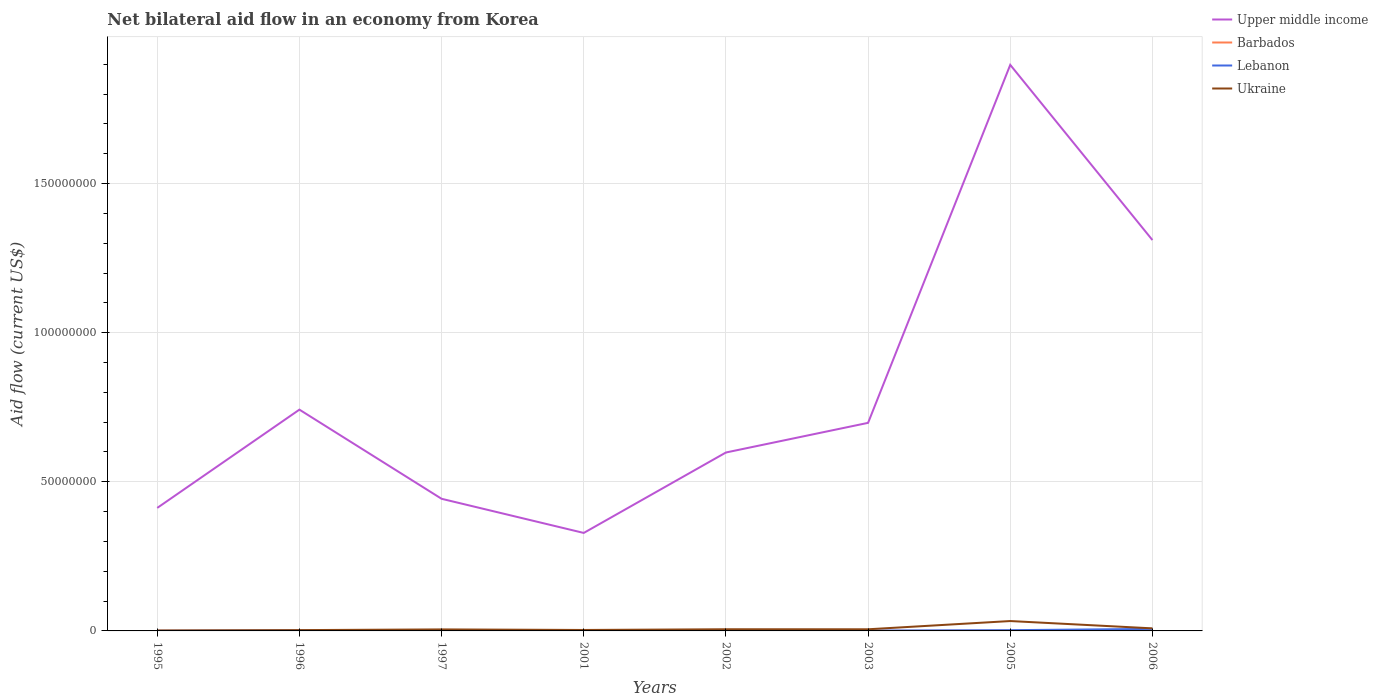How many different coloured lines are there?
Ensure brevity in your answer.  4. Across all years, what is the maximum net bilateral aid flow in Barbados?
Offer a terse response. 10000. What is the total net bilateral aid flow in Lebanon in the graph?
Offer a very short reply. -6.00e+05. What is the difference between the highest and the second highest net bilateral aid flow in Ukraine?
Provide a succinct answer. 3.17e+06. What is the difference between the highest and the lowest net bilateral aid flow in Lebanon?
Your answer should be compact. 2. How many years are there in the graph?
Make the answer very short. 8. What is the difference between two consecutive major ticks on the Y-axis?
Give a very brief answer. 5.00e+07. Are the values on the major ticks of Y-axis written in scientific E-notation?
Your answer should be compact. No. Does the graph contain grids?
Make the answer very short. Yes. Where does the legend appear in the graph?
Ensure brevity in your answer.  Top right. What is the title of the graph?
Make the answer very short. Net bilateral aid flow in an economy from Korea. What is the label or title of the X-axis?
Keep it short and to the point. Years. What is the Aid flow (current US$) in Upper middle income in 1995?
Your answer should be very brief. 4.12e+07. What is the Aid flow (current US$) in Barbados in 1995?
Offer a terse response. 3.00e+04. What is the Aid flow (current US$) in Lebanon in 1995?
Offer a very short reply. 3.00e+04. What is the Aid flow (current US$) of Upper middle income in 1996?
Provide a short and direct response. 7.42e+07. What is the Aid flow (current US$) in Upper middle income in 1997?
Offer a very short reply. 4.43e+07. What is the Aid flow (current US$) in Lebanon in 1997?
Make the answer very short. 1.20e+05. What is the Aid flow (current US$) in Ukraine in 1997?
Provide a succinct answer. 5.10e+05. What is the Aid flow (current US$) of Upper middle income in 2001?
Make the answer very short. 3.28e+07. What is the Aid flow (current US$) in Barbados in 2001?
Make the answer very short. 10000. What is the Aid flow (current US$) of Lebanon in 2001?
Offer a very short reply. 8.00e+04. What is the Aid flow (current US$) of Ukraine in 2001?
Provide a short and direct response. 3.20e+05. What is the Aid flow (current US$) of Upper middle income in 2002?
Provide a short and direct response. 5.98e+07. What is the Aid flow (current US$) of Barbados in 2002?
Your response must be concise. 9.00e+04. What is the Aid flow (current US$) in Lebanon in 2002?
Ensure brevity in your answer.  9.00e+04. What is the Aid flow (current US$) of Ukraine in 2002?
Offer a very short reply. 5.60e+05. What is the Aid flow (current US$) in Upper middle income in 2003?
Keep it short and to the point. 6.98e+07. What is the Aid flow (current US$) of Lebanon in 2003?
Offer a very short reply. 1.20e+05. What is the Aid flow (current US$) in Upper middle income in 2005?
Your response must be concise. 1.90e+08. What is the Aid flow (current US$) in Lebanon in 2005?
Your answer should be compact. 2.50e+05. What is the Aid flow (current US$) in Ukraine in 2005?
Your answer should be compact. 3.31e+06. What is the Aid flow (current US$) of Upper middle income in 2006?
Provide a succinct answer. 1.31e+08. What is the Aid flow (current US$) of Lebanon in 2006?
Offer a terse response. 6.80e+05. What is the Aid flow (current US$) of Ukraine in 2006?
Give a very brief answer. 8.60e+05. Across all years, what is the maximum Aid flow (current US$) in Upper middle income?
Keep it short and to the point. 1.90e+08. Across all years, what is the maximum Aid flow (current US$) of Barbados?
Offer a terse response. 9.00e+04. Across all years, what is the maximum Aid flow (current US$) of Lebanon?
Provide a short and direct response. 6.80e+05. Across all years, what is the maximum Aid flow (current US$) of Ukraine?
Provide a succinct answer. 3.31e+06. Across all years, what is the minimum Aid flow (current US$) of Upper middle income?
Your answer should be compact. 3.28e+07. Across all years, what is the minimum Aid flow (current US$) in Barbados?
Your response must be concise. 10000. Across all years, what is the minimum Aid flow (current US$) in Lebanon?
Provide a short and direct response. 3.00e+04. Across all years, what is the minimum Aid flow (current US$) in Ukraine?
Your response must be concise. 1.40e+05. What is the total Aid flow (current US$) in Upper middle income in the graph?
Provide a short and direct response. 6.43e+08. What is the total Aid flow (current US$) of Lebanon in the graph?
Ensure brevity in your answer.  1.52e+06. What is the total Aid flow (current US$) of Ukraine in the graph?
Your answer should be compact. 6.52e+06. What is the difference between the Aid flow (current US$) of Upper middle income in 1995 and that in 1996?
Make the answer very short. -3.30e+07. What is the difference between the Aid flow (current US$) of Barbados in 1995 and that in 1996?
Provide a short and direct response. 0. What is the difference between the Aid flow (current US$) in Upper middle income in 1995 and that in 1997?
Your answer should be compact. -3.06e+06. What is the difference between the Aid flow (current US$) in Ukraine in 1995 and that in 1997?
Offer a terse response. -3.70e+05. What is the difference between the Aid flow (current US$) in Upper middle income in 1995 and that in 2001?
Offer a very short reply. 8.39e+06. What is the difference between the Aid flow (current US$) of Barbados in 1995 and that in 2001?
Ensure brevity in your answer.  2.00e+04. What is the difference between the Aid flow (current US$) of Upper middle income in 1995 and that in 2002?
Make the answer very short. -1.86e+07. What is the difference between the Aid flow (current US$) in Barbados in 1995 and that in 2002?
Offer a terse response. -6.00e+04. What is the difference between the Aid flow (current US$) in Lebanon in 1995 and that in 2002?
Give a very brief answer. -6.00e+04. What is the difference between the Aid flow (current US$) in Ukraine in 1995 and that in 2002?
Your answer should be very brief. -4.20e+05. What is the difference between the Aid flow (current US$) of Upper middle income in 1995 and that in 2003?
Offer a very short reply. -2.85e+07. What is the difference between the Aid flow (current US$) of Barbados in 1995 and that in 2003?
Ensure brevity in your answer.  2.00e+04. What is the difference between the Aid flow (current US$) of Lebanon in 1995 and that in 2003?
Provide a short and direct response. -9.00e+04. What is the difference between the Aid flow (current US$) of Ukraine in 1995 and that in 2003?
Your response must be concise. -4.10e+05. What is the difference between the Aid flow (current US$) of Upper middle income in 1995 and that in 2005?
Offer a terse response. -1.49e+08. What is the difference between the Aid flow (current US$) of Ukraine in 1995 and that in 2005?
Make the answer very short. -3.17e+06. What is the difference between the Aid flow (current US$) of Upper middle income in 1995 and that in 2006?
Keep it short and to the point. -8.98e+07. What is the difference between the Aid flow (current US$) of Barbados in 1995 and that in 2006?
Provide a succinct answer. -2.00e+04. What is the difference between the Aid flow (current US$) of Lebanon in 1995 and that in 2006?
Provide a succinct answer. -6.50e+05. What is the difference between the Aid flow (current US$) of Ukraine in 1995 and that in 2006?
Keep it short and to the point. -7.20e+05. What is the difference between the Aid flow (current US$) of Upper middle income in 1996 and that in 1997?
Offer a terse response. 2.99e+07. What is the difference between the Aid flow (current US$) in Barbados in 1996 and that in 1997?
Your answer should be very brief. 10000. What is the difference between the Aid flow (current US$) in Upper middle income in 1996 and that in 2001?
Ensure brevity in your answer.  4.13e+07. What is the difference between the Aid flow (current US$) of Ukraine in 1996 and that in 2001?
Make the answer very short. -5.00e+04. What is the difference between the Aid flow (current US$) in Upper middle income in 1996 and that in 2002?
Ensure brevity in your answer.  1.44e+07. What is the difference between the Aid flow (current US$) in Barbados in 1996 and that in 2002?
Your answer should be compact. -6.00e+04. What is the difference between the Aid flow (current US$) of Lebanon in 1996 and that in 2002?
Provide a succinct answer. 6.00e+04. What is the difference between the Aid flow (current US$) in Upper middle income in 1996 and that in 2003?
Offer a terse response. 4.43e+06. What is the difference between the Aid flow (current US$) in Ukraine in 1996 and that in 2003?
Provide a short and direct response. -2.80e+05. What is the difference between the Aid flow (current US$) of Upper middle income in 1996 and that in 2005?
Provide a succinct answer. -1.16e+08. What is the difference between the Aid flow (current US$) in Barbados in 1996 and that in 2005?
Your answer should be very brief. -2.00e+04. What is the difference between the Aid flow (current US$) of Lebanon in 1996 and that in 2005?
Your response must be concise. -1.00e+05. What is the difference between the Aid flow (current US$) in Ukraine in 1996 and that in 2005?
Keep it short and to the point. -3.04e+06. What is the difference between the Aid flow (current US$) of Upper middle income in 1996 and that in 2006?
Offer a terse response. -5.69e+07. What is the difference between the Aid flow (current US$) of Lebanon in 1996 and that in 2006?
Your response must be concise. -5.30e+05. What is the difference between the Aid flow (current US$) in Ukraine in 1996 and that in 2006?
Make the answer very short. -5.90e+05. What is the difference between the Aid flow (current US$) of Upper middle income in 1997 and that in 2001?
Give a very brief answer. 1.14e+07. What is the difference between the Aid flow (current US$) in Upper middle income in 1997 and that in 2002?
Make the answer very short. -1.55e+07. What is the difference between the Aid flow (current US$) in Lebanon in 1997 and that in 2002?
Provide a succinct answer. 3.00e+04. What is the difference between the Aid flow (current US$) in Ukraine in 1997 and that in 2002?
Keep it short and to the point. -5.00e+04. What is the difference between the Aid flow (current US$) in Upper middle income in 1997 and that in 2003?
Provide a short and direct response. -2.55e+07. What is the difference between the Aid flow (current US$) in Barbados in 1997 and that in 2003?
Ensure brevity in your answer.  10000. What is the difference between the Aid flow (current US$) in Ukraine in 1997 and that in 2003?
Offer a very short reply. -4.00e+04. What is the difference between the Aid flow (current US$) of Upper middle income in 1997 and that in 2005?
Provide a short and direct response. -1.45e+08. What is the difference between the Aid flow (current US$) of Lebanon in 1997 and that in 2005?
Make the answer very short. -1.30e+05. What is the difference between the Aid flow (current US$) in Ukraine in 1997 and that in 2005?
Make the answer very short. -2.80e+06. What is the difference between the Aid flow (current US$) of Upper middle income in 1997 and that in 2006?
Ensure brevity in your answer.  -8.68e+07. What is the difference between the Aid flow (current US$) of Lebanon in 1997 and that in 2006?
Keep it short and to the point. -5.60e+05. What is the difference between the Aid flow (current US$) of Ukraine in 1997 and that in 2006?
Your answer should be very brief. -3.50e+05. What is the difference between the Aid flow (current US$) in Upper middle income in 2001 and that in 2002?
Your answer should be very brief. -2.70e+07. What is the difference between the Aid flow (current US$) of Ukraine in 2001 and that in 2002?
Give a very brief answer. -2.40e+05. What is the difference between the Aid flow (current US$) in Upper middle income in 2001 and that in 2003?
Offer a terse response. -3.69e+07. What is the difference between the Aid flow (current US$) in Barbados in 2001 and that in 2003?
Offer a very short reply. 0. What is the difference between the Aid flow (current US$) in Lebanon in 2001 and that in 2003?
Offer a terse response. -4.00e+04. What is the difference between the Aid flow (current US$) in Upper middle income in 2001 and that in 2005?
Your answer should be very brief. -1.57e+08. What is the difference between the Aid flow (current US$) of Ukraine in 2001 and that in 2005?
Provide a succinct answer. -2.99e+06. What is the difference between the Aid flow (current US$) in Upper middle income in 2001 and that in 2006?
Provide a short and direct response. -9.82e+07. What is the difference between the Aid flow (current US$) in Barbados in 2001 and that in 2006?
Keep it short and to the point. -4.00e+04. What is the difference between the Aid flow (current US$) in Lebanon in 2001 and that in 2006?
Keep it short and to the point. -6.00e+05. What is the difference between the Aid flow (current US$) in Ukraine in 2001 and that in 2006?
Make the answer very short. -5.40e+05. What is the difference between the Aid flow (current US$) of Upper middle income in 2002 and that in 2003?
Provide a succinct answer. -9.94e+06. What is the difference between the Aid flow (current US$) in Ukraine in 2002 and that in 2003?
Ensure brevity in your answer.  10000. What is the difference between the Aid flow (current US$) in Upper middle income in 2002 and that in 2005?
Make the answer very short. -1.30e+08. What is the difference between the Aid flow (current US$) in Barbados in 2002 and that in 2005?
Provide a succinct answer. 4.00e+04. What is the difference between the Aid flow (current US$) in Lebanon in 2002 and that in 2005?
Your response must be concise. -1.60e+05. What is the difference between the Aid flow (current US$) of Ukraine in 2002 and that in 2005?
Give a very brief answer. -2.75e+06. What is the difference between the Aid flow (current US$) of Upper middle income in 2002 and that in 2006?
Provide a short and direct response. -7.12e+07. What is the difference between the Aid flow (current US$) in Lebanon in 2002 and that in 2006?
Your answer should be compact. -5.90e+05. What is the difference between the Aid flow (current US$) in Ukraine in 2002 and that in 2006?
Your answer should be very brief. -3.00e+05. What is the difference between the Aid flow (current US$) of Upper middle income in 2003 and that in 2005?
Make the answer very short. -1.20e+08. What is the difference between the Aid flow (current US$) in Barbados in 2003 and that in 2005?
Your answer should be very brief. -4.00e+04. What is the difference between the Aid flow (current US$) of Ukraine in 2003 and that in 2005?
Give a very brief answer. -2.76e+06. What is the difference between the Aid flow (current US$) of Upper middle income in 2003 and that in 2006?
Offer a terse response. -6.13e+07. What is the difference between the Aid flow (current US$) in Barbados in 2003 and that in 2006?
Your answer should be very brief. -4.00e+04. What is the difference between the Aid flow (current US$) of Lebanon in 2003 and that in 2006?
Make the answer very short. -5.60e+05. What is the difference between the Aid flow (current US$) in Ukraine in 2003 and that in 2006?
Your answer should be very brief. -3.10e+05. What is the difference between the Aid flow (current US$) of Upper middle income in 2005 and that in 2006?
Keep it short and to the point. 5.87e+07. What is the difference between the Aid flow (current US$) in Barbados in 2005 and that in 2006?
Your answer should be compact. 0. What is the difference between the Aid flow (current US$) in Lebanon in 2005 and that in 2006?
Make the answer very short. -4.30e+05. What is the difference between the Aid flow (current US$) in Ukraine in 2005 and that in 2006?
Your response must be concise. 2.45e+06. What is the difference between the Aid flow (current US$) of Upper middle income in 1995 and the Aid flow (current US$) of Barbados in 1996?
Provide a short and direct response. 4.12e+07. What is the difference between the Aid flow (current US$) in Upper middle income in 1995 and the Aid flow (current US$) in Lebanon in 1996?
Offer a very short reply. 4.11e+07. What is the difference between the Aid flow (current US$) of Upper middle income in 1995 and the Aid flow (current US$) of Ukraine in 1996?
Your response must be concise. 4.10e+07. What is the difference between the Aid flow (current US$) in Barbados in 1995 and the Aid flow (current US$) in Lebanon in 1996?
Your answer should be very brief. -1.20e+05. What is the difference between the Aid flow (current US$) of Barbados in 1995 and the Aid flow (current US$) of Ukraine in 1996?
Ensure brevity in your answer.  -2.40e+05. What is the difference between the Aid flow (current US$) in Lebanon in 1995 and the Aid flow (current US$) in Ukraine in 1996?
Your answer should be very brief. -2.40e+05. What is the difference between the Aid flow (current US$) of Upper middle income in 1995 and the Aid flow (current US$) of Barbados in 1997?
Offer a very short reply. 4.12e+07. What is the difference between the Aid flow (current US$) of Upper middle income in 1995 and the Aid flow (current US$) of Lebanon in 1997?
Keep it short and to the point. 4.11e+07. What is the difference between the Aid flow (current US$) in Upper middle income in 1995 and the Aid flow (current US$) in Ukraine in 1997?
Keep it short and to the point. 4.07e+07. What is the difference between the Aid flow (current US$) in Barbados in 1995 and the Aid flow (current US$) in Ukraine in 1997?
Give a very brief answer. -4.80e+05. What is the difference between the Aid flow (current US$) of Lebanon in 1995 and the Aid flow (current US$) of Ukraine in 1997?
Make the answer very short. -4.80e+05. What is the difference between the Aid flow (current US$) of Upper middle income in 1995 and the Aid flow (current US$) of Barbados in 2001?
Keep it short and to the point. 4.12e+07. What is the difference between the Aid flow (current US$) in Upper middle income in 1995 and the Aid flow (current US$) in Lebanon in 2001?
Provide a short and direct response. 4.12e+07. What is the difference between the Aid flow (current US$) in Upper middle income in 1995 and the Aid flow (current US$) in Ukraine in 2001?
Make the answer very short. 4.09e+07. What is the difference between the Aid flow (current US$) in Barbados in 1995 and the Aid flow (current US$) in Ukraine in 2001?
Offer a terse response. -2.90e+05. What is the difference between the Aid flow (current US$) in Upper middle income in 1995 and the Aid flow (current US$) in Barbados in 2002?
Give a very brief answer. 4.12e+07. What is the difference between the Aid flow (current US$) in Upper middle income in 1995 and the Aid flow (current US$) in Lebanon in 2002?
Keep it short and to the point. 4.12e+07. What is the difference between the Aid flow (current US$) of Upper middle income in 1995 and the Aid flow (current US$) of Ukraine in 2002?
Offer a terse response. 4.07e+07. What is the difference between the Aid flow (current US$) of Barbados in 1995 and the Aid flow (current US$) of Lebanon in 2002?
Your answer should be very brief. -6.00e+04. What is the difference between the Aid flow (current US$) in Barbados in 1995 and the Aid flow (current US$) in Ukraine in 2002?
Provide a short and direct response. -5.30e+05. What is the difference between the Aid flow (current US$) in Lebanon in 1995 and the Aid flow (current US$) in Ukraine in 2002?
Provide a succinct answer. -5.30e+05. What is the difference between the Aid flow (current US$) of Upper middle income in 1995 and the Aid flow (current US$) of Barbados in 2003?
Provide a succinct answer. 4.12e+07. What is the difference between the Aid flow (current US$) of Upper middle income in 1995 and the Aid flow (current US$) of Lebanon in 2003?
Make the answer very short. 4.11e+07. What is the difference between the Aid flow (current US$) of Upper middle income in 1995 and the Aid flow (current US$) of Ukraine in 2003?
Ensure brevity in your answer.  4.07e+07. What is the difference between the Aid flow (current US$) of Barbados in 1995 and the Aid flow (current US$) of Ukraine in 2003?
Offer a very short reply. -5.20e+05. What is the difference between the Aid flow (current US$) of Lebanon in 1995 and the Aid flow (current US$) of Ukraine in 2003?
Provide a succinct answer. -5.20e+05. What is the difference between the Aid flow (current US$) in Upper middle income in 1995 and the Aid flow (current US$) in Barbados in 2005?
Provide a succinct answer. 4.12e+07. What is the difference between the Aid flow (current US$) of Upper middle income in 1995 and the Aid flow (current US$) of Lebanon in 2005?
Your answer should be very brief. 4.10e+07. What is the difference between the Aid flow (current US$) in Upper middle income in 1995 and the Aid flow (current US$) in Ukraine in 2005?
Give a very brief answer. 3.79e+07. What is the difference between the Aid flow (current US$) of Barbados in 1995 and the Aid flow (current US$) of Ukraine in 2005?
Your answer should be very brief. -3.28e+06. What is the difference between the Aid flow (current US$) of Lebanon in 1995 and the Aid flow (current US$) of Ukraine in 2005?
Offer a terse response. -3.28e+06. What is the difference between the Aid flow (current US$) in Upper middle income in 1995 and the Aid flow (current US$) in Barbados in 2006?
Give a very brief answer. 4.12e+07. What is the difference between the Aid flow (current US$) in Upper middle income in 1995 and the Aid flow (current US$) in Lebanon in 2006?
Provide a succinct answer. 4.06e+07. What is the difference between the Aid flow (current US$) of Upper middle income in 1995 and the Aid flow (current US$) of Ukraine in 2006?
Offer a very short reply. 4.04e+07. What is the difference between the Aid flow (current US$) in Barbados in 1995 and the Aid flow (current US$) in Lebanon in 2006?
Offer a very short reply. -6.50e+05. What is the difference between the Aid flow (current US$) of Barbados in 1995 and the Aid flow (current US$) of Ukraine in 2006?
Provide a short and direct response. -8.30e+05. What is the difference between the Aid flow (current US$) of Lebanon in 1995 and the Aid flow (current US$) of Ukraine in 2006?
Provide a short and direct response. -8.30e+05. What is the difference between the Aid flow (current US$) in Upper middle income in 1996 and the Aid flow (current US$) in Barbados in 1997?
Offer a terse response. 7.42e+07. What is the difference between the Aid flow (current US$) in Upper middle income in 1996 and the Aid flow (current US$) in Lebanon in 1997?
Keep it short and to the point. 7.41e+07. What is the difference between the Aid flow (current US$) in Upper middle income in 1996 and the Aid flow (current US$) in Ukraine in 1997?
Your answer should be compact. 7.37e+07. What is the difference between the Aid flow (current US$) of Barbados in 1996 and the Aid flow (current US$) of Ukraine in 1997?
Offer a very short reply. -4.80e+05. What is the difference between the Aid flow (current US$) of Lebanon in 1996 and the Aid flow (current US$) of Ukraine in 1997?
Offer a very short reply. -3.60e+05. What is the difference between the Aid flow (current US$) of Upper middle income in 1996 and the Aid flow (current US$) of Barbados in 2001?
Offer a terse response. 7.42e+07. What is the difference between the Aid flow (current US$) in Upper middle income in 1996 and the Aid flow (current US$) in Lebanon in 2001?
Offer a very short reply. 7.41e+07. What is the difference between the Aid flow (current US$) of Upper middle income in 1996 and the Aid flow (current US$) of Ukraine in 2001?
Keep it short and to the point. 7.39e+07. What is the difference between the Aid flow (current US$) in Lebanon in 1996 and the Aid flow (current US$) in Ukraine in 2001?
Give a very brief answer. -1.70e+05. What is the difference between the Aid flow (current US$) in Upper middle income in 1996 and the Aid flow (current US$) in Barbados in 2002?
Offer a terse response. 7.41e+07. What is the difference between the Aid flow (current US$) in Upper middle income in 1996 and the Aid flow (current US$) in Lebanon in 2002?
Offer a very short reply. 7.41e+07. What is the difference between the Aid flow (current US$) of Upper middle income in 1996 and the Aid flow (current US$) of Ukraine in 2002?
Provide a short and direct response. 7.36e+07. What is the difference between the Aid flow (current US$) in Barbados in 1996 and the Aid flow (current US$) in Lebanon in 2002?
Offer a terse response. -6.00e+04. What is the difference between the Aid flow (current US$) in Barbados in 1996 and the Aid flow (current US$) in Ukraine in 2002?
Ensure brevity in your answer.  -5.30e+05. What is the difference between the Aid flow (current US$) of Lebanon in 1996 and the Aid flow (current US$) of Ukraine in 2002?
Offer a terse response. -4.10e+05. What is the difference between the Aid flow (current US$) of Upper middle income in 1996 and the Aid flow (current US$) of Barbados in 2003?
Your answer should be very brief. 7.42e+07. What is the difference between the Aid flow (current US$) in Upper middle income in 1996 and the Aid flow (current US$) in Lebanon in 2003?
Your answer should be compact. 7.41e+07. What is the difference between the Aid flow (current US$) in Upper middle income in 1996 and the Aid flow (current US$) in Ukraine in 2003?
Your response must be concise. 7.36e+07. What is the difference between the Aid flow (current US$) in Barbados in 1996 and the Aid flow (current US$) in Lebanon in 2003?
Your answer should be very brief. -9.00e+04. What is the difference between the Aid flow (current US$) in Barbados in 1996 and the Aid flow (current US$) in Ukraine in 2003?
Your answer should be compact. -5.20e+05. What is the difference between the Aid flow (current US$) of Lebanon in 1996 and the Aid flow (current US$) of Ukraine in 2003?
Offer a terse response. -4.00e+05. What is the difference between the Aid flow (current US$) in Upper middle income in 1996 and the Aid flow (current US$) in Barbados in 2005?
Ensure brevity in your answer.  7.41e+07. What is the difference between the Aid flow (current US$) of Upper middle income in 1996 and the Aid flow (current US$) of Lebanon in 2005?
Your response must be concise. 7.39e+07. What is the difference between the Aid flow (current US$) in Upper middle income in 1996 and the Aid flow (current US$) in Ukraine in 2005?
Provide a short and direct response. 7.09e+07. What is the difference between the Aid flow (current US$) in Barbados in 1996 and the Aid flow (current US$) in Ukraine in 2005?
Give a very brief answer. -3.28e+06. What is the difference between the Aid flow (current US$) of Lebanon in 1996 and the Aid flow (current US$) of Ukraine in 2005?
Your answer should be very brief. -3.16e+06. What is the difference between the Aid flow (current US$) of Upper middle income in 1996 and the Aid flow (current US$) of Barbados in 2006?
Provide a succinct answer. 7.41e+07. What is the difference between the Aid flow (current US$) of Upper middle income in 1996 and the Aid flow (current US$) of Lebanon in 2006?
Provide a short and direct response. 7.35e+07. What is the difference between the Aid flow (current US$) in Upper middle income in 1996 and the Aid flow (current US$) in Ukraine in 2006?
Provide a succinct answer. 7.33e+07. What is the difference between the Aid flow (current US$) of Barbados in 1996 and the Aid flow (current US$) of Lebanon in 2006?
Your answer should be very brief. -6.50e+05. What is the difference between the Aid flow (current US$) in Barbados in 1996 and the Aid flow (current US$) in Ukraine in 2006?
Ensure brevity in your answer.  -8.30e+05. What is the difference between the Aid flow (current US$) of Lebanon in 1996 and the Aid flow (current US$) of Ukraine in 2006?
Offer a terse response. -7.10e+05. What is the difference between the Aid flow (current US$) in Upper middle income in 1997 and the Aid flow (current US$) in Barbados in 2001?
Offer a terse response. 4.43e+07. What is the difference between the Aid flow (current US$) in Upper middle income in 1997 and the Aid flow (current US$) in Lebanon in 2001?
Ensure brevity in your answer.  4.42e+07. What is the difference between the Aid flow (current US$) of Upper middle income in 1997 and the Aid flow (current US$) of Ukraine in 2001?
Your answer should be very brief. 4.40e+07. What is the difference between the Aid flow (current US$) of Barbados in 1997 and the Aid flow (current US$) of Lebanon in 2001?
Give a very brief answer. -6.00e+04. What is the difference between the Aid flow (current US$) in Barbados in 1997 and the Aid flow (current US$) in Ukraine in 2001?
Offer a terse response. -3.00e+05. What is the difference between the Aid flow (current US$) in Upper middle income in 1997 and the Aid flow (current US$) in Barbados in 2002?
Your answer should be compact. 4.42e+07. What is the difference between the Aid flow (current US$) in Upper middle income in 1997 and the Aid flow (current US$) in Lebanon in 2002?
Your answer should be compact. 4.42e+07. What is the difference between the Aid flow (current US$) in Upper middle income in 1997 and the Aid flow (current US$) in Ukraine in 2002?
Your answer should be very brief. 4.37e+07. What is the difference between the Aid flow (current US$) in Barbados in 1997 and the Aid flow (current US$) in Ukraine in 2002?
Offer a very short reply. -5.40e+05. What is the difference between the Aid flow (current US$) of Lebanon in 1997 and the Aid flow (current US$) of Ukraine in 2002?
Make the answer very short. -4.40e+05. What is the difference between the Aid flow (current US$) of Upper middle income in 1997 and the Aid flow (current US$) of Barbados in 2003?
Provide a short and direct response. 4.43e+07. What is the difference between the Aid flow (current US$) of Upper middle income in 1997 and the Aid flow (current US$) of Lebanon in 2003?
Your answer should be very brief. 4.42e+07. What is the difference between the Aid flow (current US$) of Upper middle income in 1997 and the Aid flow (current US$) of Ukraine in 2003?
Your response must be concise. 4.38e+07. What is the difference between the Aid flow (current US$) in Barbados in 1997 and the Aid flow (current US$) in Ukraine in 2003?
Provide a short and direct response. -5.30e+05. What is the difference between the Aid flow (current US$) in Lebanon in 1997 and the Aid flow (current US$) in Ukraine in 2003?
Make the answer very short. -4.30e+05. What is the difference between the Aid flow (current US$) of Upper middle income in 1997 and the Aid flow (current US$) of Barbados in 2005?
Provide a succinct answer. 4.42e+07. What is the difference between the Aid flow (current US$) in Upper middle income in 1997 and the Aid flow (current US$) in Lebanon in 2005?
Keep it short and to the point. 4.40e+07. What is the difference between the Aid flow (current US$) in Upper middle income in 1997 and the Aid flow (current US$) in Ukraine in 2005?
Give a very brief answer. 4.10e+07. What is the difference between the Aid flow (current US$) of Barbados in 1997 and the Aid flow (current US$) of Lebanon in 2005?
Your answer should be very brief. -2.30e+05. What is the difference between the Aid flow (current US$) of Barbados in 1997 and the Aid flow (current US$) of Ukraine in 2005?
Ensure brevity in your answer.  -3.29e+06. What is the difference between the Aid flow (current US$) of Lebanon in 1997 and the Aid flow (current US$) of Ukraine in 2005?
Your answer should be very brief. -3.19e+06. What is the difference between the Aid flow (current US$) of Upper middle income in 1997 and the Aid flow (current US$) of Barbados in 2006?
Offer a very short reply. 4.42e+07. What is the difference between the Aid flow (current US$) in Upper middle income in 1997 and the Aid flow (current US$) in Lebanon in 2006?
Offer a terse response. 4.36e+07. What is the difference between the Aid flow (current US$) of Upper middle income in 1997 and the Aid flow (current US$) of Ukraine in 2006?
Keep it short and to the point. 4.34e+07. What is the difference between the Aid flow (current US$) of Barbados in 1997 and the Aid flow (current US$) of Lebanon in 2006?
Make the answer very short. -6.60e+05. What is the difference between the Aid flow (current US$) of Barbados in 1997 and the Aid flow (current US$) of Ukraine in 2006?
Provide a short and direct response. -8.40e+05. What is the difference between the Aid flow (current US$) in Lebanon in 1997 and the Aid flow (current US$) in Ukraine in 2006?
Ensure brevity in your answer.  -7.40e+05. What is the difference between the Aid flow (current US$) of Upper middle income in 2001 and the Aid flow (current US$) of Barbados in 2002?
Provide a succinct answer. 3.28e+07. What is the difference between the Aid flow (current US$) in Upper middle income in 2001 and the Aid flow (current US$) in Lebanon in 2002?
Provide a short and direct response. 3.28e+07. What is the difference between the Aid flow (current US$) of Upper middle income in 2001 and the Aid flow (current US$) of Ukraine in 2002?
Give a very brief answer. 3.23e+07. What is the difference between the Aid flow (current US$) in Barbados in 2001 and the Aid flow (current US$) in Ukraine in 2002?
Give a very brief answer. -5.50e+05. What is the difference between the Aid flow (current US$) in Lebanon in 2001 and the Aid flow (current US$) in Ukraine in 2002?
Offer a very short reply. -4.80e+05. What is the difference between the Aid flow (current US$) in Upper middle income in 2001 and the Aid flow (current US$) in Barbados in 2003?
Provide a short and direct response. 3.28e+07. What is the difference between the Aid flow (current US$) of Upper middle income in 2001 and the Aid flow (current US$) of Lebanon in 2003?
Provide a succinct answer. 3.27e+07. What is the difference between the Aid flow (current US$) of Upper middle income in 2001 and the Aid flow (current US$) of Ukraine in 2003?
Your response must be concise. 3.23e+07. What is the difference between the Aid flow (current US$) in Barbados in 2001 and the Aid flow (current US$) in Ukraine in 2003?
Your answer should be very brief. -5.40e+05. What is the difference between the Aid flow (current US$) in Lebanon in 2001 and the Aid flow (current US$) in Ukraine in 2003?
Provide a short and direct response. -4.70e+05. What is the difference between the Aid flow (current US$) of Upper middle income in 2001 and the Aid flow (current US$) of Barbados in 2005?
Provide a short and direct response. 3.28e+07. What is the difference between the Aid flow (current US$) of Upper middle income in 2001 and the Aid flow (current US$) of Lebanon in 2005?
Provide a short and direct response. 3.26e+07. What is the difference between the Aid flow (current US$) in Upper middle income in 2001 and the Aid flow (current US$) in Ukraine in 2005?
Your answer should be compact. 2.95e+07. What is the difference between the Aid flow (current US$) of Barbados in 2001 and the Aid flow (current US$) of Lebanon in 2005?
Ensure brevity in your answer.  -2.40e+05. What is the difference between the Aid flow (current US$) in Barbados in 2001 and the Aid flow (current US$) in Ukraine in 2005?
Provide a succinct answer. -3.30e+06. What is the difference between the Aid flow (current US$) in Lebanon in 2001 and the Aid flow (current US$) in Ukraine in 2005?
Your answer should be very brief. -3.23e+06. What is the difference between the Aid flow (current US$) of Upper middle income in 2001 and the Aid flow (current US$) of Barbados in 2006?
Offer a very short reply. 3.28e+07. What is the difference between the Aid flow (current US$) in Upper middle income in 2001 and the Aid flow (current US$) in Lebanon in 2006?
Ensure brevity in your answer.  3.22e+07. What is the difference between the Aid flow (current US$) in Upper middle income in 2001 and the Aid flow (current US$) in Ukraine in 2006?
Your response must be concise. 3.20e+07. What is the difference between the Aid flow (current US$) of Barbados in 2001 and the Aid flow (current US$) of Lebanon in 2006?
Make the answer very short. -6.70e+05. What is the difference between the Aid flow (current US$) in Barbados in 2001 and the Aid flow (current US$) in Ukraine in 2006?
Your response must be concise. -8.50e+05. What is the difference between the Aid flow (current US$) of Lebanon in 2001 and the Aid flow (current US$) of Ukraine in 2006?
Your answer should be compact. -7.80e+05. What is the difference between the Aid flow (current US$) of Upper middle income in 2002 and the Aid flow (current US$) of Barbados in 2003?
Your response must be concise. 5.98e+07. What is the difference between the Aid flow (current US$) of Upper middle income in 2002 and the Aid flow (current US$) of Lebanon in 2003?
Give a very brief answer. 5.97e+07. What is the difference between the Aid flow (current US$) of Upper middle income in 2002 and the Aid flow (current US$) of Ukraine in 2003?
Make the answer very short. 5.93e+07. What is the difference between the Aid flow (current US$) in Barbados in 2002 and the Aid flow (current US$) in Ukraine in 2003?
Your response must be concise. -4.60e+05. What is the difference between the Aid flow (current US$) of Lebanon in 2002 and the Aid flow (current US$) of Ukraine in 2003?
Provide a short and direct response. -4.60e+05. What is the difference between the Aid flow (current US$) of Upper middle income in 2002 and the Aid flow (current US$) of Barbados in 2005?
Make the answer very short. 5.98e+07. What is the difference between the Aid flow (current US$) of Upper middle income in 2002 and the Aid flow (current US$) of Lebanon in 2005?
Ensure brevity in your answer.  5.96e+07. What is the difference between the Aid flow (current US$) in Upper middle income in 2002 and the Aid flow (current US$) in Ukraine in 2005?
Provide a succinct answer. 5.65e+07. What is the difference between the Aid flow (current US$) in Barbados in 2002 and the Aid flow (current US$) in Ukraine in 2005?
Your response must be concise. -3.22e+06. What is the difference between the Aid flow (current US$) in Lebanon in 2002 and the Aid flow (current US$) in Ukraine in 2005?
Your answer should be compact. -3.22e+06. What is the difference between the Aid flow (current US$) of Upper middle income in 2002 and the Aid flow (current US$) of Barbados in 2006?
Provide a short and direct response. 5.98e+07. What is the difference between the Aid flow (current US$) of Upper middle income in 2002 and the Aid flow (current US$) of Lebanon in 2006?
Give a very brief answer. 5.91e+07. What is the difference between the Aid flow (current US$) of Upper middle income in 2002 and the Aid flow (current US$) of Ukraine in 2006?
Offer a terse response. 5.90e+07. What is the difference between the Aid flow (current US$) in Barbados in 2002 and the Aid flow (current US$) in Lebanon in 2006?
Make the answer very short. -5.90e+05. What is the difference between the Aid flow (current US$) of Barbados in 2002 and the Aid flow (current US$) of Ukraine in 2006?
Offer a very short reply. -7.70e+05. What is the difference between the Aid flow (current US$) of Lebanon in 2002 and the Aid flow (current US$) of Ukraine in 2006?
Provide a short and direct response. -7.70e+05. What is the difference between the Aid flow (current US$) of Upper middle income in 2003 and the Aid flow (current US$) of Barbados in 2005?
Offer a very short reply. 6.97e+07. What is the difference between the Aid flow (current US$) in Upper middle income in 2003 and the Aid flow (current US$) in Lebanon in 2005?
Your response must be concise. 6.95e+07. What is the difference between the Aid flow (current US$) in Upper middle income in 2003 and the Aid flow (current US$) in Ukraine in 2005?
Keep it short and to the point. 6.64e+07. What is the difference between the Aid flow (current US$) in Barbados in 2003 and the Aid flow (current US$) in Lebanon in 2005?
Offer a terse response. -2.40e+05. What is the difference between the Aid flow (current US$) in Barbados in 2003 and the Aid flow (current US$) in Ukraine in 2005?
Ensure brevity in your answer.  -3.30e+06. What is the difference between the Aid flow (current US$) of Lebanon in 2003 and the Aid flow (current US$) of Ukraine in 2005?
Give a very brief answer. -3.19e+06. What is the difference between the Aid flow (current US$) of Upper middle income in 2003 and the Aid flow (current US$) of Barbados in 2006?
Keep it short and to the point. 6.97e+07. What is the difference between the Aid flow (current US$) of Upper middle income in 2003 and the Aid flow (current US$) of Lebanon in 2006?
Your answer should be very brief. 6.91e+07. What is the difference between the Aid flow (current US$) in Upper middle income in 2003 and the Aid flow (current US$) in Ukraine in 2006?
Offer a very short reply. 6.89e+07. What is the difference between the Aid flow (current US$) of Barbados in 2003 and the Aid flow (current US$) of Lebanon in 2006?
Your answer should be very brief. -6.70e+05. What is the difference between the Aid flow (current US$) of Barbados in 2003 and the Aid flow (current US$) of Ukraine in 2006?
Your answer should be compact. -8.50e+05. What is the difference between the Aid flow (current US$) of Lebanon in 2003 and the Aid flow (current US$) of Ukraine in 2006?
Make the answer very short. -7.40e+05. What is the difference between the Aid flow (current US$) in Upper middle income in 2005 and the Aid flow (current US$) in Barbados in 2006?
Give a very brief answer. 1.90e+08. What is the difference between the Aid flow (current US$) of Upper middle income in 2005 and the Aid flow (current US$) of Lebanon in 2006?
Your answer should be compact. 1.89e+08. What is the difference between the Aid flow (current US$) of Upper middle income in 2005 and the Aid flow (current US$) of Ukraine in 2006?
Provide a short and direct response. 1.89e+08. What is the difference between the Aid flow (current US$) of Barbados in 2005 and the Aid flow (current US$) of Lebanon in 2006?
Ensure brevity in your answer.  -6.30e+05. What is the difference between the Aid flow (current US$) of Barbados in 2005 and the Aid flow (current US$) of Ukraine in 2006?
Your response must be concise. -8.10e+05. What is the difference between the Aid flow (current US$) in Lebanon in 2005 and the Aid flow (current US$) in Ukraine in 2006?
Your response must be concise. -6.10e+05. What is the average Aid flow (current US$) of Upper middle income per year?
Your answer should be very brief. 8.04e+07. What is the average Aid flow (current US$) of Barbados per year?
Make the answer very short. 3.62e+04. What is the average Aid flow (current US$) in Ukraine per year?
Ensure brevity in your answer.  8.15e+05. In the year 1995, what is the difference between the Aid flow (current US$) of Upper middle income and Aid flow (current US$) of Barbados?
Make the answer very short. 4.12e+07. In the year 1995, what is the difference between the Aid flow (current US$) of Upper middle income and Aid flow (current US$) of Lebanon?
Provide a succinct answer. 4.12e+07. In the year 1995, what is the difference between the Aid flow (current US$) of Upper middle income and Aid flow (current US$) of Ukraine?
Your answer should be very brief. 4.11e+07. In the year 1995, what is the difference between the Aid flow (current US$) of Barbados and Aid flow (current US$) of Ukraine?
Your answer should be compact. -1.10e+05. In the year 1995, what is the difference between the Aid flow (current US$) in Lebanon and Aid flow (current US$) in Ukraine?
Your response must be concise. -1.10e+05. In the year 1996, what is the difference between the Aid flow (current US$) of Upper middle income and Aid flow (current US$) of Barbados?
Provide a succinct answer. 7.42e+07. In the year 1996, what is the difference between the Aid flow (current US$) in Upper middle income and Aid flow (current US$) in Lebanon?
Your answer should be compact. 7.40e+07. In the year 1996, what is the difference between the Aid flow (current US$) of Upper middle income and Aid flow (current US$) of Ukraine?
Your answer should be very brief. 7.39e+07. In the year 1997, what is the difference between the Aid flow (current US$) of Upper middle income and Aid flow (current US$) of Barbados?
Give a very brief answer. 4.43e+07. In the year 1997, what is the difference between the Aid flow (current US$) of Upper middle income and Aid flow (current US$) of Lebanon?
Offer a terse response. 4.42e+07. In the year 1997, what is the difference between the Aid flow (current US$) in Upper middle income and Aid flow (current US$) in Ukraine?
Provide a short and direct response. 4.38e+07. In the year 1997, what is the difference between the Aid flow (current US$) of Barbados and Aid flow (current US$) of Ukraine?
Ensure brevity in your answer.  -4.90e+05. In the year 1997, what is the difference between the Aid flow (current US$) in Lebanon and Aid flow (current US$) in Ukraine?
Make the answer very short. -3.90e+05. In the year 2001, what is the difference between the Aid flow (current US$) in Upper middle income and Aid flow (current US$) in Barbados?
Offer a very short reply. 3.28e+07. In the year 2001, what is the difference between the Aid flow (current US$) in Upper middle income and Aid flow (current US$) in Lebanon?
Give a very brief answer. 3.28e+07. In the year 2001, what is the difference between the Aid flow (current US$) of Upper middle income and Aid flow (current US$) of Ukraine?
Provide a short and direct response. 3.25e+07. In the year 2001, what is the difference between the Aid flow (current US$) in Barbados and Aid flow (current US$) in Lebanon?
Provide a short and direct response. -7.00e+04. In the year 2001, what is the difference between the Aid flow (current US$) of Barbados and Aid flow (current US$) of Ukraine?
Your answer should be very brief. -3.10e+05. In the year 2002, what is the difference between the Aid flow (current US$) in Upper middle income and Aid flow (current US$) in Barbados?
Provide a short and direct response. 5.97e+07. In the year 2002, what is the difference between the Aid flow (current US$) of Upper middle income and Aid flow (current US$) of Lebanon?
Offer a very short reply. 5.97e+07. In the year 2002, what is the difference between the Aid flow (current US$) in Upper middle income and Aid flow (current US$) in Ukraine?
Provide a succinct answer. 5.93e+07. In the year 2002, what is the difference between the Aid flow (current US$) in Barbados and Aid flow (current US$) in Ukraine?
Your answer should be compact. -4.70e+05. In the year 2002, what is the difference between the Aid flow (current US$) in Lebanon and Aid flow (current US$) in Ukraine?
Offer a very short reply. -4.70e+05. In the year 2003, what is the difference between the Aid flow (current US$) in Upper middle income and Aid flow (current US$) in Barbados?
Make the answer very short. 6.98e+07. In the year 2003, what is the difference between the Aid flow (current US$) of Upper middle income and Aid flow (current US$) of Lebanon?
Keep it short and to the point. 6.96e+07. In the year 2003, what is the difference between the Aid flow (current US$) of Upper middle income and Aid flow (current US$) of Ukraine?
Make the answer very short. 6.92e+07. In the year 2003, what is the difference between the Aid flow (current US$) in Barbados and Aid flow (current US$) in Lebanon?
Ensure brevity in your answer.  -1.10e+05. In the year 2003, what is the difference between the Aid flow (current US$) in Barbados and Aid flow (current US$) in Ukraine?
Offer a terse response. -5.40e+05. In the year 2003, what is the difference between the Aid flow (current US$) of Lebanon and Aid flow (current US$) of Ukraine?
Provide a short and direct response. -4.30e+05. In the year 2005, what is the difference between the Aid flow (current US$) of Upper middle income and Aid flow (current US$) of Barbados?
Offer a terse response. 1.90e+08. In the year 2005, what is the difference between the Aid flow (current US$) of Upper middle income and Aid flow (current US$) of Lebanon?
Your answer should be very brief. 1.90e+08. In the year 2005, what is the difference between the Aid flow (current US$) in Upper middle income and Aid flow (current US$) in Ukraine?
Your response must be concise. 1.86e+08. In the year 2005, what is the difference between the Aid flow (current US$) in Barbados and Aid flow (current US$) in Lebanon?
Make the answer very short. -2.00e+05. In the year 2005, what is the difference between the Aid flow (current US$) of Barbados and Aid flow (current US$) of Ukraine?
Provide a succinct answer. -3.26e+06. In the year 2005, what is the difference between the Aid flow (current US$) in Lebanon and Aid flow (current US$) in Ukraine?
Your answer should be very brief. -3.06e+06. In the year 2006, what is the difference between the Aid flow (current US$) of Upper middle income and Aid flow (current US$) of Barbados?
Provide a succinct answer. 1.31e+08. In the year 2006, what is the difference between the Aid flow (current US$) of Upper middle income and Aid flow (current US$) of Lebanon?
Provide a succinct answer. 1.30e+08. In the year 2006, what is the difference between the Aid flow (current US$) in Upper middle income and Aid flow (current US$) in Ukraine?
Provide a succinct answer. 1.30e+08. In the year 2006, what is the difference between the Aid flow (current US$) in Barbados and Aid flow (current US$) in Lebanon?
Offer a terse response. -6.30e+05. In the year 2006, what is the difference between the Aid flow (current US$) in Barbados and Aid flow (current US$) in Ukraine?
Make the answer very short. -8.10e+05. In the year 2006, what is the difference between the Aid flow (current US$) of Lebanon and Aid flow (current US$) of Ukraine?
Give a very brief answer. -1.80e+05. What is the ratio of the Aid flow (current US$) in Upper middle income in 1995 to that in 1996?
Provide a short and direct response. 0.56. What is the ratio of the Aid flow (current US$) of Barbados in 1995 to that in 1996?
Your answer should be compact. 1. What is the ratio of the Aid flow (current US$) in Ukraine in 1995 to that in 1996?
Make the answer very short. 0.52. What is the ratio of the Aid flow (current US$) in Upper middle income in 1995 to that in 1997?
Provide a short and direct response. 0.93. What is the ratio of the Aid flow (current US$) in Ukraine in 1995 to that in 1997?
Offer a very short reply. 0.27. What is the ratio of the Aid flow (current US$) of Upper middle income in 1995 to that in 2001?
Provide a succinct answer. 1.26. What is the ratio of the Aid flow (current US$) in Ukraine in 1995 to that in 2001?
Give a very brief answer. 0.44. What is the ratio of the Aid flow (current US$) of Upper middle income in 1995 to that in 2002?
Offer a very short reply. 0.69. What is the ratio of the Aid flow (current US$) in Barbados in 1995 to that in 2002?
Your response must be concise. 0.33. What is the ratio of the Aid flow (current US$) of Ukraine in 1995 to that in 2002?
Ensure brevity in your answer.  0.25. What is the ratio of the Aid flow (current US$) of Upper middle income in 1995 to that in 2003?
Your answer should be very brief. 0.59. What is the ratio of the Aid flow (current US$) of Barbados in 1995 to that in 2003?
Ensure brevity in your answer.  3. What is the ratio of the Aid flow (current US$) of Ukraine in 1995 to that in 2003?
Your answer should be very brief. 0.25. What is the ratio of the Aid flow (current US$) in Upper middle income in 1995 to that in 2005?
Provide a succinct answer. 0.22. What is the ratio of the Aid flow (current US$) in Barbados in 1995 to that in 2005?
Ensure brevity in your answer.  0.6. What is the ratio of the Aid flow (current US$) in Lebanon in 1995 to that in 2005?
Provide a succinct answer. 0.12. What is the ratio of the Aid flow (current US$) in Ukraine in 1995 to that in 2005?
Ensure brevity in your answer.  0.04. What is the ratio of the Aid flow (current US$) of Upper middle income in 1995 to that in 2006?
Provide a succinct answer. 0.31. What is the ratio of the Aid flow (current US$) in Lebanon in 1995 to that in 2006?
Make the answer very short. 0.04. What is the ratio of the Aid flow (current US$) of Ukraine in 1995 to that in 2006?
Give a very brief answer. 0.16. What is the ratio of the Aid flow (current US$) of Upper middle income in 1996 to that in 1997?
Your answer should be very brief. 1.67. What is the ratio of the Aid flow (current US$) of Ukraine in 1996 to that in 1997?
Provide a succinct answer. 0.53. What is the ratio of the Aid flow (current US$) of Upper middle income in 1996 to that in 2001?
Offer a very short reply. 2.26. What is the ratio of the Aid flow (current US$) of Lebanon in 1996 to that in 2001?
Your answer should be very brief. 1.88. What is the ratio of the Aid flow (current US$) of Ukraine in 1996 to that in 2001?
Make the answer very short. 0.84. What is the ratio of the Aid flow (current US$) of Upper middle income in 1996 to that in 2002?
Provide a short and direct response. 1.24. What is the ratio of the Aid flow (current US$) in Barbados in 1996 to that in 2002?
Your answer should be compact. 0.33. What is the ratio of the Aid flow (current US$) of Ukraine in 1996 to that in 2002?
Make the answer very short. 0.48. What is the ratio of the Aid flow (current US$) in Upper middle income in 1996 to that in 2003?
Offer a very short reply. 1.06. What is the ratio of the Aid flow (current US$) in Barbados in 1996 to that in 2003?
Offer a very short reply. 3. What is the ratio of the Aid flow (current US$) in Ukraine in 1996 to that in 2003?
Offer a terse response. 0.49. What is the ratio of the Aid flow (current US$) in Upper middle income in 1996 to that in 2005?
Offer a terse response. 0.39. What is the ratio of the Aid flow (current US$) in Barbados in 1996 to that in 2005?
Keep it short and to the point. 0.6. What is the ratio of the Aid flow (current US$) in Ukraine in 1996 to that in 2005?
Make the answer very short. 0.08. What is the ratio of the Aid flow (current US$) of Upper middle income in 1996 to that in 2006?
Offer a very short reply. 0.57. What is the ratio of the Aid flow (current US$) of Barbados in 1996 to that in 2006?
Keep it short and to the point. 0.6. What is the ratio of the Aid flow (current US$) of Lebanon in 1996 to that in 2006?
Offer a very short reply. 0.22. What is the ratio of the Aid flow (current US$) of Ukraine in 1996 to that in 2006?
Your answer should be compact. 0.31. What is the ratio of the Aid flow (current US$) in Upper middle income in 1997 to that in 2001?
Give a very brief answer. 1.35. What is the ratio of the Aid flow (current US$) of Lebanon in 1997 to that in 2001?
Provide a short and direct response. 1.5. What is the ratio of the Aid flow (current US$) of Ukraine in 1997 to that in 2001?
Offer a very short reply. 1.59. What is the ratio of the Aid flow (current US$) of Upper middle income in 1997 to that in 2002?
Provide a succinct answer. 0.74. What is the ratio of the Aid flow (current US$) of Barbados in 1997 to that in 2002?
Make the answer very short. 0.22. What is the ratio of the Aid flow (current US$) of Ukraine in 1997 to that in 2002?
Ensure brevity in your answer.  0.91. What is the ratio of the Aid flow (current US$) of Upper middle income in 1997 to that in 2003?
Provide a short and direct response. 0.64. What is the ratio of the Aid flow (current US$) of Barbados in 1997 to that in 2003?
Provide a succinct answer. 2. What is the ratio of the Aid flow (current US$) in Ukraine in 1997 to that in 2003?
Offer a terse response. 0.93. What is the ratio of the Aid flow (current US$) in Upper middle income in 1997 to that in 2005?
Make the answer very short. 0.23. What is the ratio of the Aid flow (current US$) of Barbados in 1997 to that in 2005?
Provide a succinct answer. 0.4. What is the ratio of the Aid flow (current US$) of Lebanon in 1997 to that in 2005?
Your answer should be compact. 0.48. What is the ratio of the Aid flow (current US$) in Ukraine in 1997 to that in 2005?
Keep it short and to the point. 0.15. What is the ratio of the Aid flow (current US$) of Upper middle income in 1997 to that in 2006?
Make the answer very short. 0.34. What is the ratio of the Aid flow (current US$) of Barbados in 1997 to that in 2006?
Your response must be concise. 0.4. What is the ratio of the Aid flow (current US$) of Lebanon in 1997 to that in 2006?
Your answer should be very brief. 0.18. What is the ratio of the Aid flow (current US$) in Ukraine in 1997 to that in 2006?
Keep it short and to the point. 0.59. What is the ratio of the Aid flow (current US$) of Upper middle income in 2001 to that in 2002?
Give a very brief answer. 0.55. What is the ratio of the Aid flow (current US$) of Lebanon in 2001 to that in 2002?
Give a very brief answer. 0.89. What is the ratio of the Aid flow (current US$) in Ukraine in 2001 to that in 2002?
Provide a short and direct response. 0.57. What is the ratio of the Aid flow (current US$) of Upper middle income in 2001 to that in 2003?
Provide a succinct answer. 0.47. What is the ratio of the Aid flow (current US$) in Barbados in 2001 to that in 2003?
Your response must be concise. 1. What is the ratio of the Aid flow (current US$) in Lebanon in 2001 to that in 2003?
Your answer should be compact. 0.67. What is the ratio of the Aid flow (current US$) in Ukraine in 2001 to that in 2003?
Give a very brief answer. 0.58. What is the ratio of the Aid flow (current US$) of Upper middle income in 2001 to that in 2005?
Keep it short and to the point. 0.17. What is the ratio of the Aid flow (current US$) in Lebanon in 2001 to that in 2005?
Provide a short and direct response. 0.32. What is the ratio of the Aid flow (current US$) in Ukraine in 2001 to that in 2005?
Keep it short and to the point. 0.1. What is the ratio of the Aid flow (current US$) in Upper middle income in 2001 to that in 2006?
Give a very brief answer. 0.25. What is the ratio of the Aid flow (current US$) in Barbados in 2001 to that in 2006?
Offer a very short reply. 0.2. What is the ratio of the Aid flow (current US$) of Lebanon in 2001 to that in 2006?
Your response must be concise. 0.12. What is the ratio of the Aid flow (current US$) of Ukraine in 2001 to that in 2006?
Your answer should be very brief. 0.37. What is the ratio of the Aid flow (current US$) in Upper middle income in 2002 to that in 2003?
Offer a very short reply. 0.86. What is the ratio of the Aid flow (current US$) of Ukraine in 2002 to that in 2003?
Your answer should be compact. 1.02. What is the ratio of the Aid flow (current US$) of Upper middle income in 2002 to that in 2005?
Give a very brief answer. 0.32. What is the ratio of the Aid flow (current US$) of Lebanon in 2002 to that in 2005?
Ensure brevity in your answer.  0.36. What is the ratio of the Aid flow (current US$) of Ukraine in 2002 to that in 2005?
Provide a short and direct response. 0.17. What is the ratio of the Aid flow (current US$) of Upper middle income in 2002 to that in 2006?
Provide a succinct answer. 0.46. What is the ratio of the Aid flow (current US$) in Barbados in 2002 to that in 2006?
Offer a very short reply. 1.8. What is the ratio of the Aid flow (current US$) in Lebanon in 2002 to that in 2006?
Offer a very short reply. 0.13. What is the ratio of the Aid flow (current US$) of Ukraine in 2002 to that in 2006?
Provide a short and direct response. 0.65. What is the ratio of the Aid flow (current US$) of Upper middle income in 2003 to that in 2005?
Provide a succinct answer. 0.37. What is the ratio of the Aid flow (current US$) in Lebanon in 2003 to that in 2005?
Provide a short and direct response. 0.48. What is the ratio of the Aid flow (current US$) of Ukraine in 2003 to that in 2005?
Make the answer very short. 0.17. What is the ratio of the Aid flow (current US$) of Upper middle income in 2003 to that in 2006?
Your answer should be very brief. 0.53. What is the ratio of the Aid flow (current US$) of Lebanon in 2003 to that in 2006?
Ensure brevity in your answer.  0.18. What is the ratio of the Aid flow (current US$) of Ukraine in 2003 to that in 2006?
Offer a very short reply. 0.64. What is the ratio of the Aid flow (current US$) in Upper middle income in 2005 to that in 2006?
Your answer should be compact. 1.45. What is the ratio of the Aid flow (current US$) of Lebanon in 2005 to that in 2006?
Your response must be concise. 0.37. What is the ratio of the Aid flow (current US$) in Ukraine in 2005 to that in 2006?
Your answer should be very brief. 3.85. What is the difference between the highest and the second highest Aid flow (current US$) in Upper middle income?
Your answer should be compact. 5.87e+07. What is the difference between the highest and the second highest Aid flow (current US$) of Barbados?
Provide a short and direct response. 4.00e+04. What is the difference between the highest and the second highest Aid flow (current US$) of Lebanon?
Provide a short and direct response. 4.30e+05. What is the difference between the highest and the second highest Aid flow (current US$) in Ukraine?
Your answer should be compact. 2.45e+06. What is the difference between the highest and the lowest Aid flow (current US$) of Upper middle income?
Ensure brevity in your answer.  1.57e+08. What is the difference between the highest and the lowest Aid flow (current US$) of Barbados?
Your answer should be very brief. 8.00e+04. What is the difference between the highest and the lowest Aid flow (current US$) in Lebanon?
Provide a short and direct response. 6.50e+05. What is the difference between the highest and the lowest Aid flow (current US$) in Ukraine?
Give a very brief answer. 3.17e+06. 